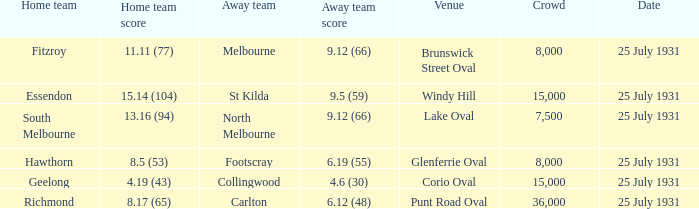With fitzroy as the home team, what was the score for the away team? 9.12 (66). 